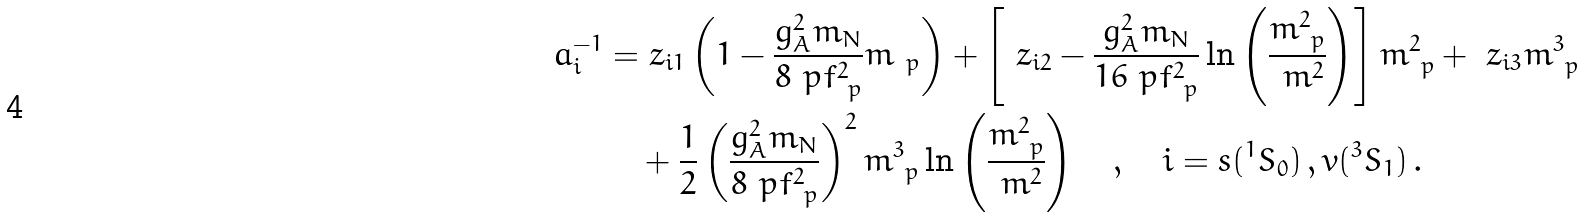Convert formula to latex. <formula><loc_0><loc_0><loc_500><loc_500>a ^ { - 1 } _ { i } = & \ z _ { i 1 } \left ( 1 - \frac { g ^ { 2 } _ { A } m _ { N } } { 8 \ p f ^ { 2 } _ { \ p } } m _ { \ p } \right ) + \left [ \ z _ { i 2 } - \frac { g _ { A } ^ { 2 } m _ { N } } { 1 6 \ p f ^ { 2 } _ { \ p } } \ln \left ( \frac { m ^ { 2 } _ { \ p } } { \ m ^ { 2 } } \right ) \right ] m ^ { 2 } _ { \ p } + \ z _ { i 3 } m ^ { 3 } _ { \ p } \\ & + \frac { 1 } { 2 } \left ( \frac { g ^ { 2 } _ { A } m _ { N } } { 8 \ p f ^ { 2 } _ { \ p } } \right ) ^ { 2 } m ^ { 3 } _ { \ p } \ln \left ( \frac { m ^ { 2 } _ { \ p } } { \ m ^ { 2 } } \right ) \quad , \quad i = s ( ^ { 1 } S _ { 0 } ) \, , v ( ^ { 3 } S _ { 1 } ) \, .</formula> 